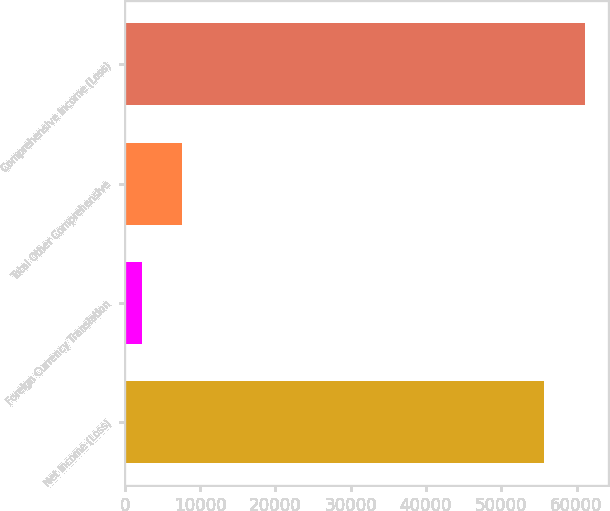Convert chart to OTSL. <chart><loc_0><loc_0><loc_500><loc_500><bar_chart><fcel>Net Income (Loss)<fcel>Foreign Currency Translation<fcel>Total Other Comprehensive<fcel>Comprehensive Income (Loss)<nl><fcel>55737.7<fcel>2288<fcel>7635.7<fcel>61085.4<nl></chart> 